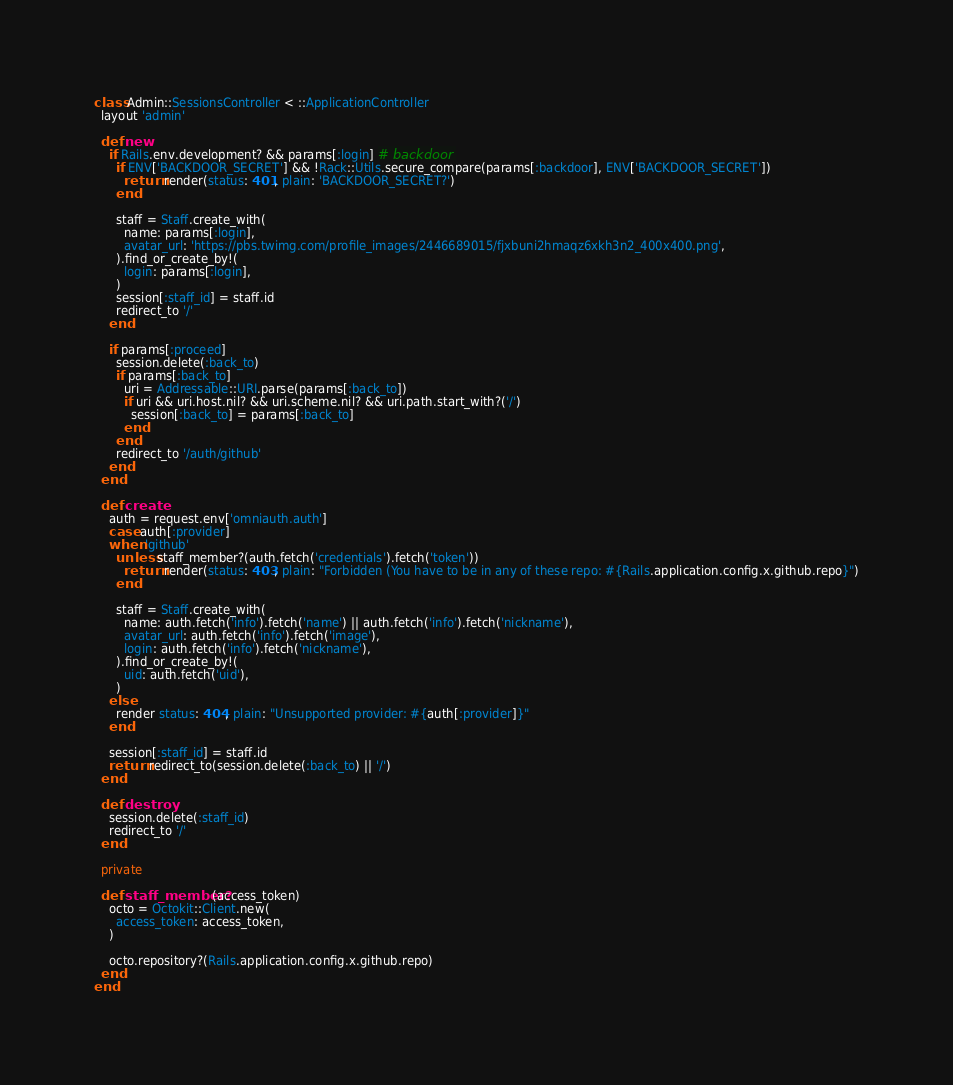Convert code to text. <code><loc_0><loc_0><loc_500><loc_500><_Ruby_>class Admin::SessionsController < ::ApplicationController
  layout 'admin'

  def new
    if Rails.env.development? && params[:login] # backdoor
      if ENV['BACKDOOR_SECRET'] && !Rack::Utils.secure_compare(params[:backdoor], ENV['BACKDOOR_SECRET'])
        return render(status: 401, plain: 'BACKDOOR_SECRET?')
      end

      staff = Staff.create_with(
        name: params[:login],
        avatar_url: 'https://pbs.twimg.com/profile_images/2446689015/fjxbuni2hmaqz6xkh3n2_400x400.png',
      ).find_or_create_by!(
        login: params[:login],
      )
      session[:staff_id] = staff.id
      redirect_to '/'
    end

    if params[:proceed]
      session.delete(:back_to)
      if params[:back_to]
        uri = Addressable::URI.parse(params[:back_to])
        if uri && uri.host.nil? && uri.scheme.nil? && uri.path.start_with?('/')
          session[:back_to] = params[:back_to]
        end
      end
      redirect_to '/auth/github'
    end
  end

  def create
    auth = request.env['omniauth.auth']
    case auth[:provider]
    when 'github'
      unless staff_member?(auth.fetch('credentials').fetch('token'))
        return render(status: 403, plain: "Forbidden (You have to be in any of these repo: #{Rails.application.config.x.github.repo}")
      end

      staff = Staff.create_with(
        name: auth.fetch('info').fetch('name') || auth.fetch('info').fetch('nickname'),
        avatar_url: auth.fetch('info').fetch('image'),
        login: auth.fetch('info').fetch('nickname'),
      ).find_or_create_by!(
        uid: auth.fetch('uid'),
      )
    else
      render status: 404, plain: "Unsupported provider: #{auth[:provider]}"
    end

    session[:staff_id] = staff.id
    return redirect_to(session.delete(:back_to) || '/')
  end

  def destroy
    session.delete(:staff_id)
    redirect_to '/'
  end

  private

  def staff_member?(access_token)
    octo = Octokit::Client.new(
      access_token: access_token,
    )

    octo.repository?(Rails.application.config.x.github.repo)
  end
end
</code> 